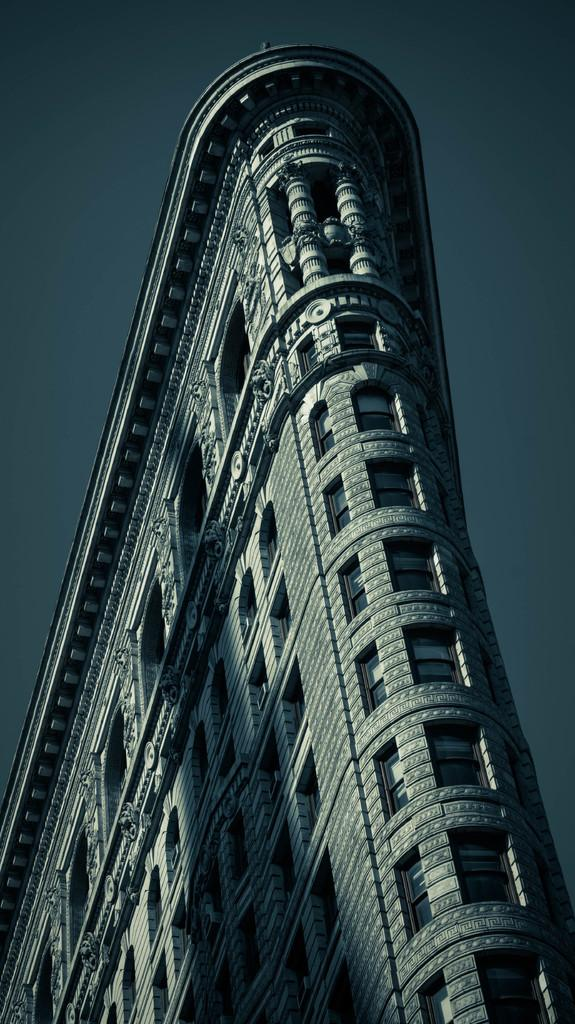What type of structure is the main subject in the image? There is a tall building in the image. What can be observed about the windows of the building? The building has small windows. What is visible in the background of the image? There is a sky visible in the image. What type of brass instrument is being played by the family in the image? There is no brass instrument or family present in the image; it only features a tall building with small windows and a visible sky. 